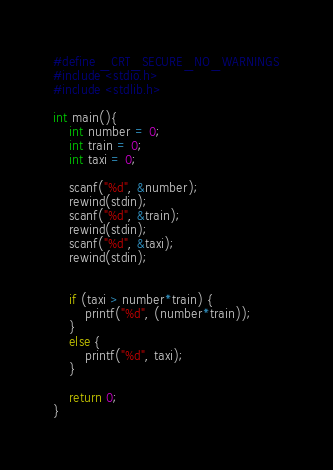Convert code to text. <code><loc_0><loc_0><loc_500><loc_500><_C_>#define _CRT_SECURE_NO_WARNINGS
#include <stdio.h>
#include <stdlib.h>

int main(){
	int number = 0;
	int train = 0;
	int taxi = 0;

	scanf("%d", &number);
	rewind(stdin);
	scanf("%d", &train);
	rewind(stdin);
	scanf("%d", &taxi);
	rewind(stdin);


	if (taxi > number*train) {
		printf("%d", (number*train));
	}
	else {
		printf("%d", taxi);
	}

	return 0;
}</code> 